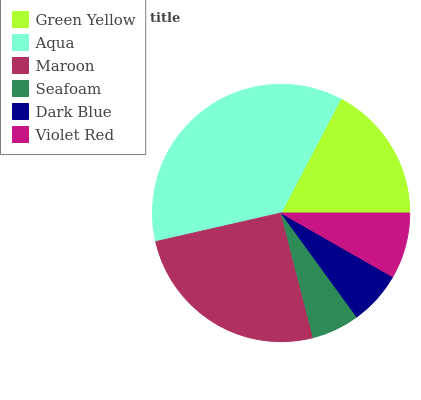Is Seafoam the minimum?
Answer yes or no. Yes. Is Aqua the maximum?
Answer yes or no. Yes. Is Maroon the minimum?
Answer yes or no. No. Is Maroon the maximum?
Answer yes or no. No. Is Aqua greater than Maroon?
Answer yes or no. Yes. Is Maroon less than Aqua?
Answer yes or no. Yes. Is Maroon greater than Aqua?
Answer yes or no. No. Is Aqua less than Maroon?
Answer yes or no. No. Is Green Yellow the high median?
Answer yes or no. Yes. Is Violet Red the low median?
Answer yes or no. Yes. Is Seafoam the high median?
Answer yes or no. No. Is Green Yellow the low median?
Answer yes or no. No. 